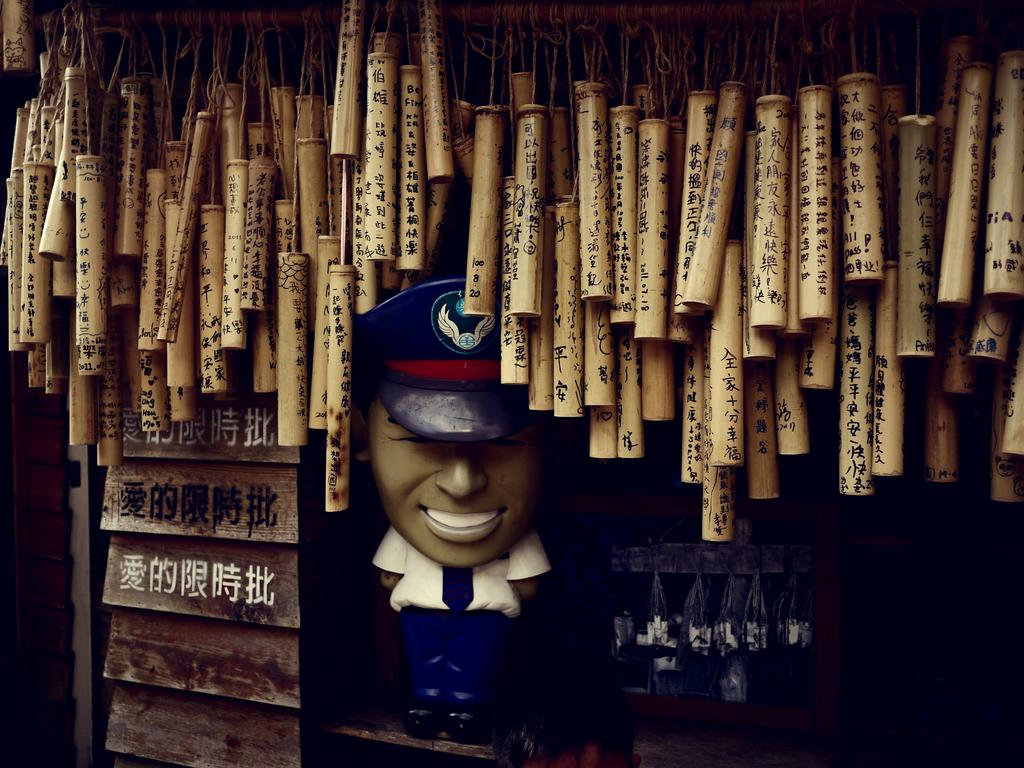<image>
Render a clear and concise summary of the photo. One of the tubes over the statue of an airline captain features the numbers 100, 8, and 20. 